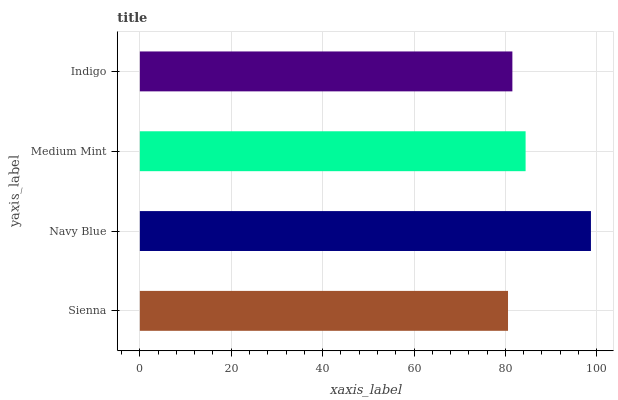Is Sienna the minimum?
Answer yes or no. Yes. Is Navy Blue the maximum?
Answer yes or no. Yes. Is Medium Mint the minimum?
Answer yes or no. No. Is Medium Mint the maximum?
Answer yes or no. No. Is Navy Blue greater than Medium Mint?
Answer yes or no. Yes. Is Medium Mint less than Navy Blue?
Answer yes or no. Yes. Is Medium Mint greater than Navy Blue?
Answer yes or no. No. Is Navy Blue less than Medium Mint?
Answer yes or no. No. Is Medium Mint the high median?
Answer yes or no. Yes. Is Indigo the low median?
Answer yes or no. Yes. Is Navy Blue the high median?
Answer yes or no. No. Is Medium Mint the low median?
Answer yes or no. No. 